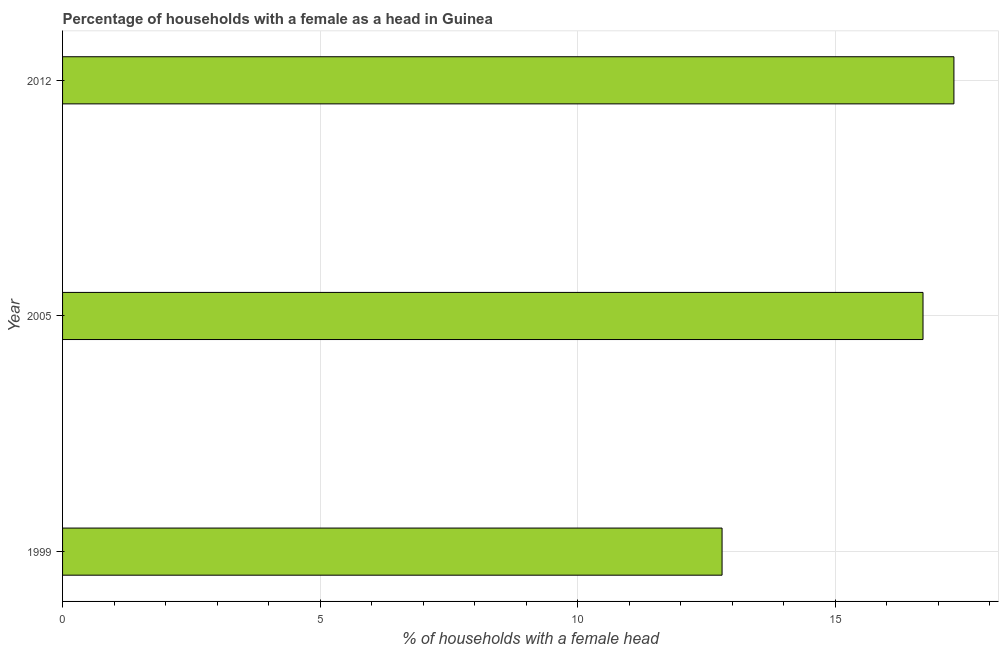Does the graph contain grids?
Your response must be concise. Yes. What is the title of the graph?
Keep it short and to the point. Percentage of households with a female as a head in Guinea. What is the label or title of the X-axis?
Provide a short and direct response. % of households with a female head. What is the number of female supervised households in 2005?
Offer a terse response. 16.7. Across all years, what is the minimum number of female supervised households?
Provide a succinct answer. 12.8. What is the sum of the number of female supervised households?
Offer a terse response. 46.8. Do a majority of the years between 1999 and 2005 (inclusive) have number of female supervised households greater than 17 %?
Provide a succinct answer. No. What is the ratio of the number of female supervised households in 2005 to that in 2012?
Your answer should be very brief. 0.96. Is the difference between the number of female supervised households in 2005 and 2012 greater than the difference between any two years?
Keep it short and to the point. No. Is the sum of the number of female supervised households in 1999 and 2012 greater than the maximum number of female supervised households across all years?
Offer a terse response. Yes. What is the difference between the highest and the lowest number of female supervised households?
Your answer should be compact. 4.5. How many bars are there?
Offer a very short reply. 3. Are the values on the major ticks of X-axis written in scientific E-notation?
Your response must be concise. No. What is the % of households with a female head of 2005?
Your answer should be compact. 16.7. What is the difference between the % of households with a female head in 1999 and 2005?
Your answer should be very brief. -3.9. What is the ratio of the % of households with a female head in 1999 to that in 2005?
Offer a terse response. 0.77. What is the ratio of the % of households with a female head in 1999 to that in 2012?
Your answer should be compact. 0.74. 